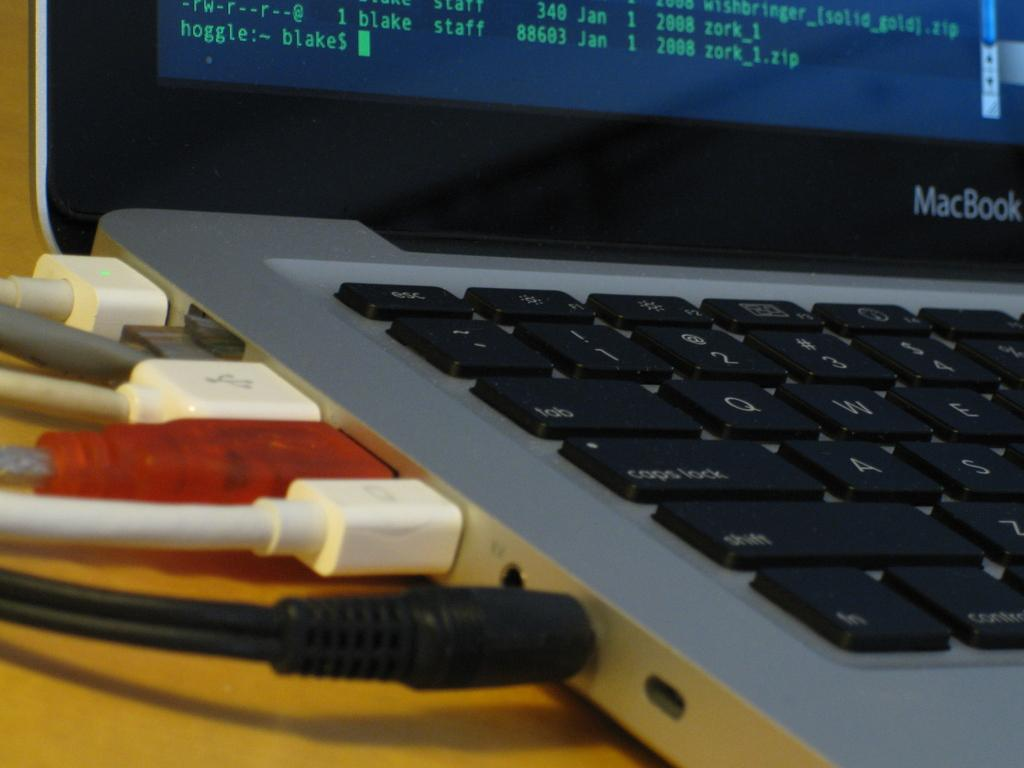<image>
Provide a brief description of the given image. An Apple MacBook laptop with numerous cords plugged in the side of the laptop. 